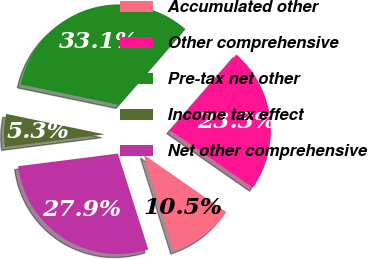Convert chart to OTSL. <chart><loc_0><loc_0><loc_500><loc_500><pie_chart><fcel>Accumulated other<fcel>Other comprehensive<fcel>Pre-tax net other<fcel>Income tax effect<fcel>Net other comprehensive<nl><fcel>10.45%<fcel>23.26%<fcel>33.14%<fcel>5.27%<fcel>27.87%<nl></chart> 